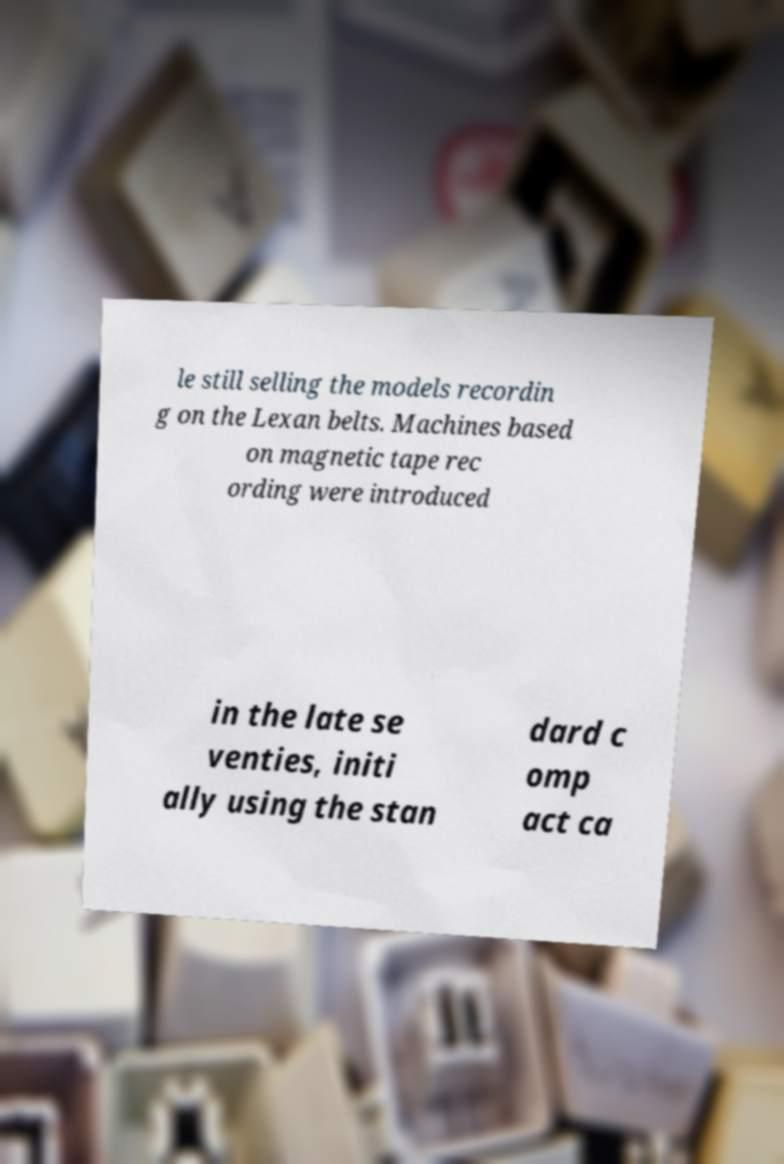For documentation purposes, I need the text within this image transcribed. Could you provide that? le still selling the models recordin g on the Lexan belts. Machines based on magnetic tape rec ording were introduced in the late se venties, initi ally using the stan dard c omp act ca 